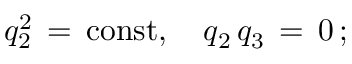<formula> <loc_0><loc_0><loc_500><loc_500>q _ { 2 } ^ { 2 } \, = \, c o n s t , \quad q _ { 2 } \, q _ { 3 } \, = \, 0 \, { ; }</formula> 